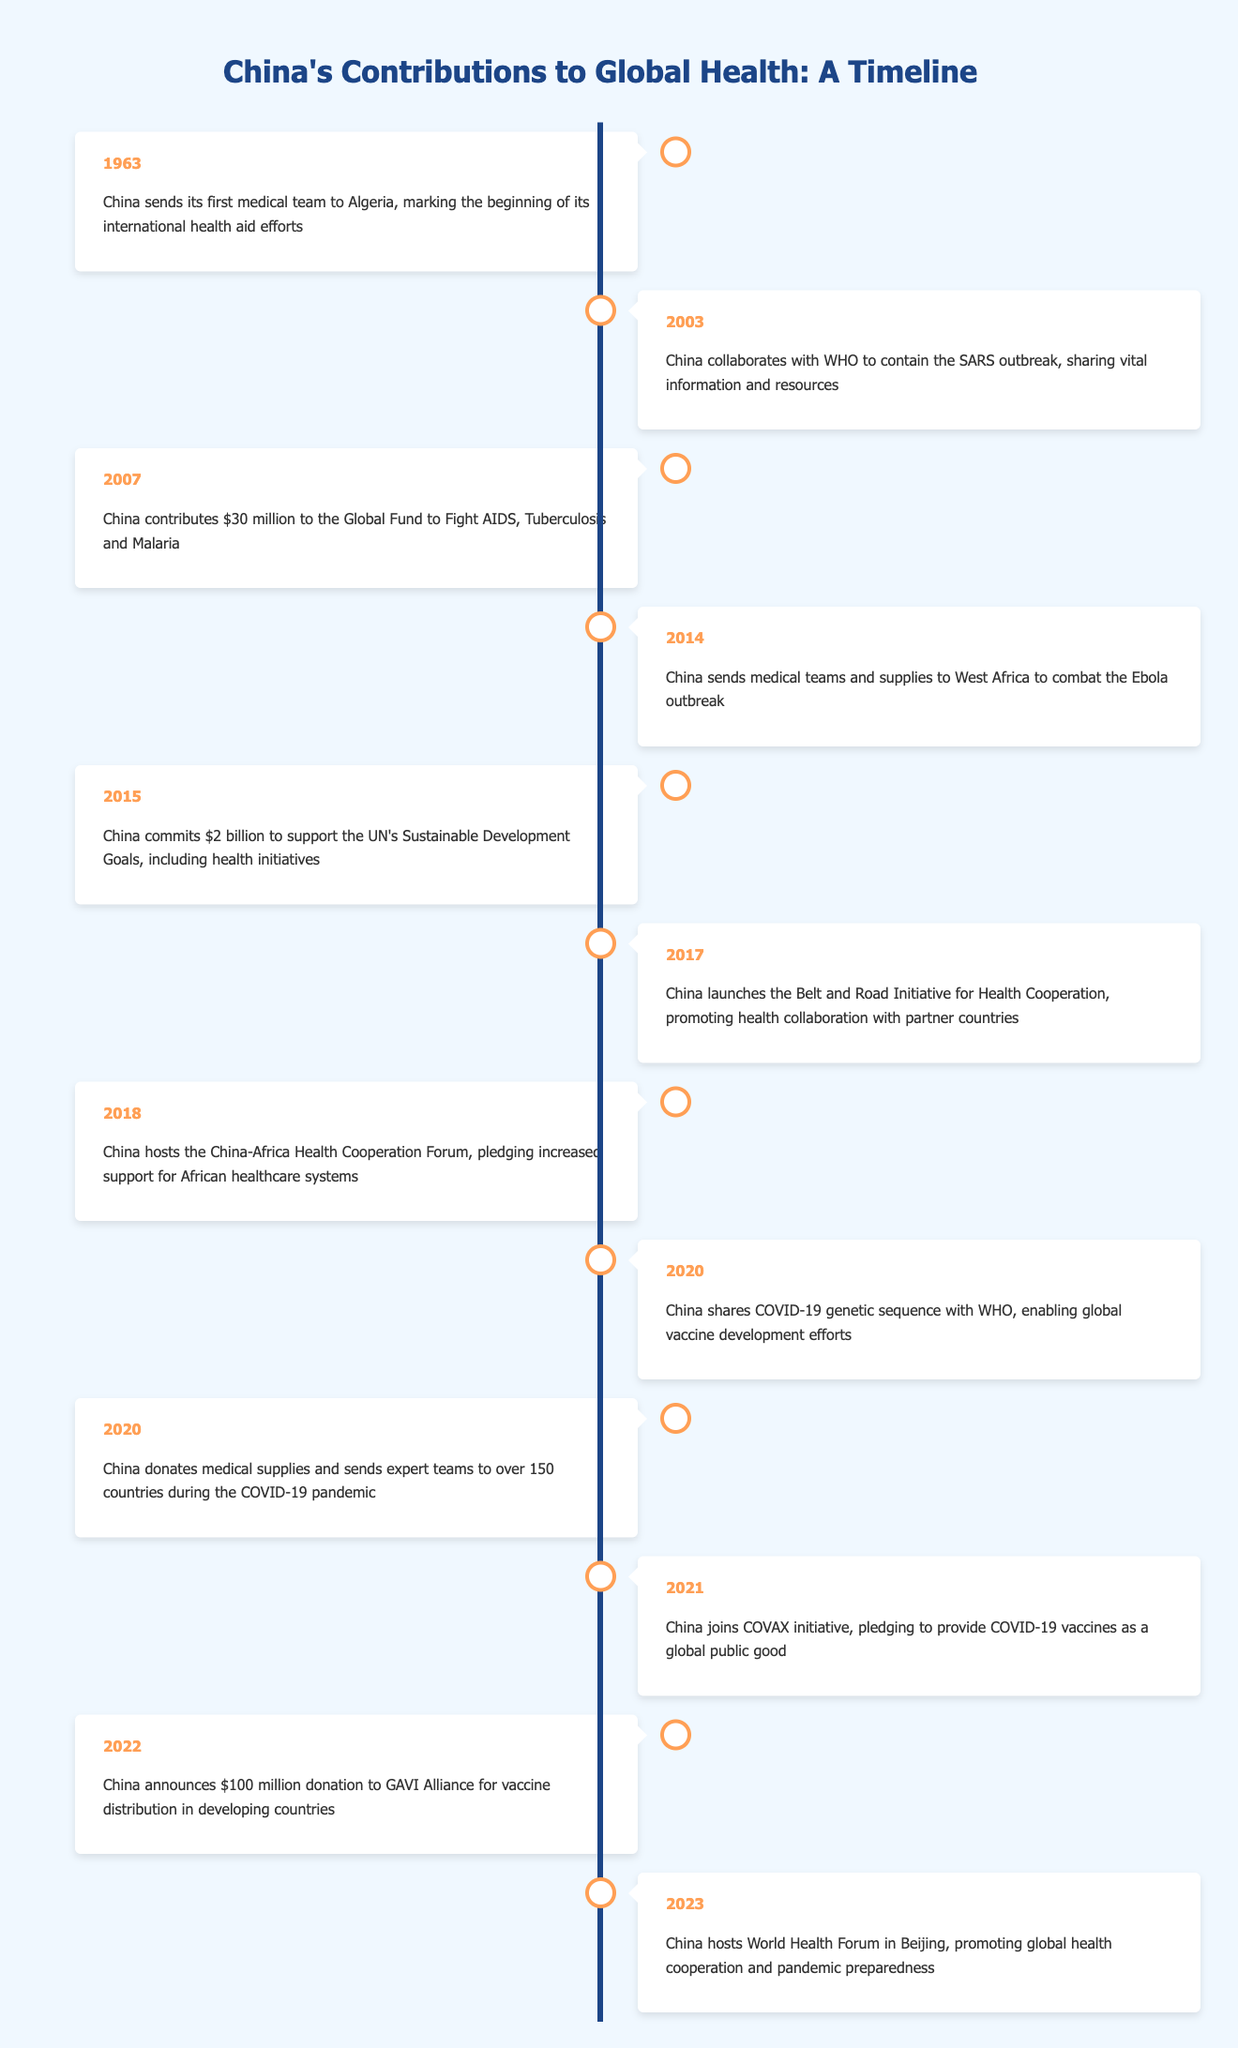What year did China first send a medical team abroad? The table lists the year 1963, which is when China sent its first medical team to Algeria. This event marks the beginning of its international health aid efforts.
Answer: 1963 How much did China commit to support the UN's Sustainable Development Goals in 2015? The table indicates that in 2015, China committed $2 billion to support the UN's Sustainable Development Goals, which includes health initiatives.
Answer: $2 billion Is it true that China collaborated with WHO for the SARS outbreak in 2003? The table confirms that in 2003, China collaborated with WHO to contain the SARS outbreak by sharing vital information and resources, indicating that this statement is true.
Answer: Yes What events related to health initiatives did China participate in from 2014 to 2018? The events listed during these years are: in 2014, China sent medical teams and supplies to combat the Ebola outbreak; in 2015, it committed $2 billion to the UN's Sustainable Development Goals; in 2017, it launched the Belt and Road Initiative for Health Cooperation; and in 2018, it hosted the China-Africa Health Cooperation Forum, pledging increased support for African healthcare systems.
Answer: In 2014, 2015, 2017, and 2018 In which year did China donate medical supplies to over 150 countries? According to the table, China donated medical supplies and sent expert teams to over 150 countries during the COVID-19 pandemic in 2020.
Answer: 2020 How many years are there between China's first medical team in 1963 and its commitment of $30 million to the Global Fund in 2007? The difference between 2007 and 1963 is 44 years, which is calculated by subtracting 1963 from 2007.
Answer: 44 years What is the total amount China contributed to health initiatives from 2007 to 2022? China contributed $30 million in 2007, $2 billion in 2015, and $100 million in 2022. Summing these amounts gives $30 million + $2 billion + $100 million = $2.13 billion.
Answer: $2.13 billion Did China host the World Health Forum before 2023? The table only lists the event in 2023, indicating that China hosted the World Health Forum in that year but does not mention any prior hosting of such an event. Therefore, this statement is false.
Answer: No What initiative did China join in 2021 regarding COVID-19 vaccines? In 2021, China joined the COVAX initiative, pledging to provide COVID-19 vaccines as a global public good which signifies its commitment to global health.
Answer: COVAX initiative 